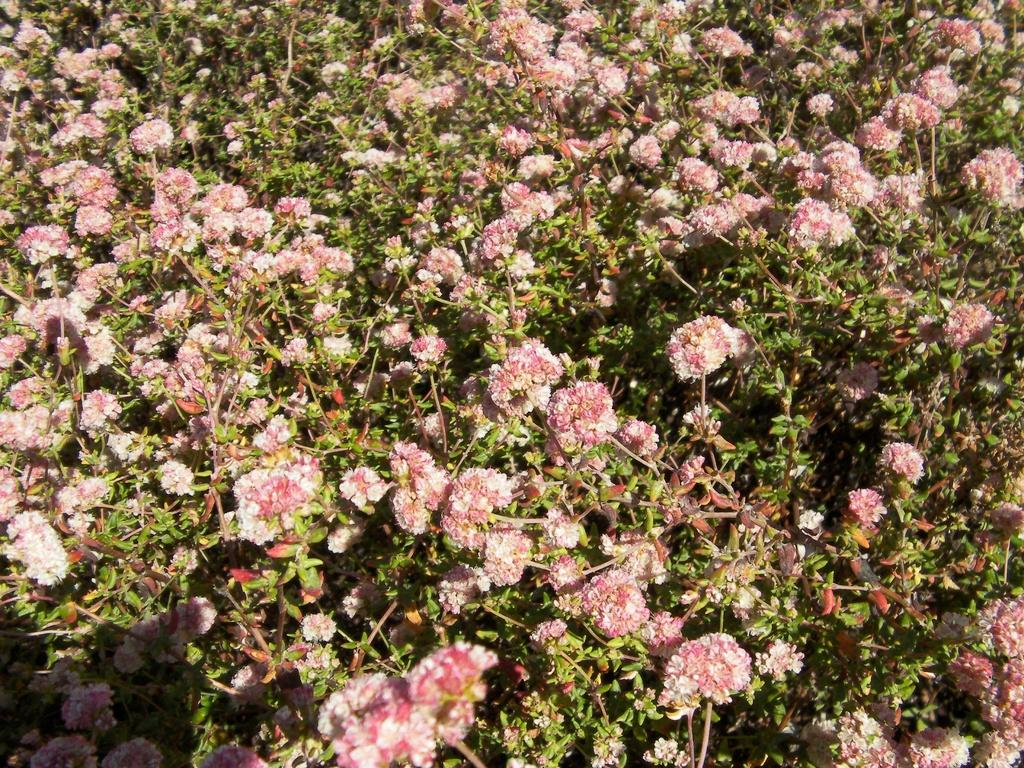What is the main subject of the image? The main subject of the image is many plants. What specific feature do the plants have? The plants have flowers. What color are the flowers? The flowers are pink in color. What type of yarn is used to create the flowers in the image? There is no yarn present in the image; the flowers are natural and part of the plants. 